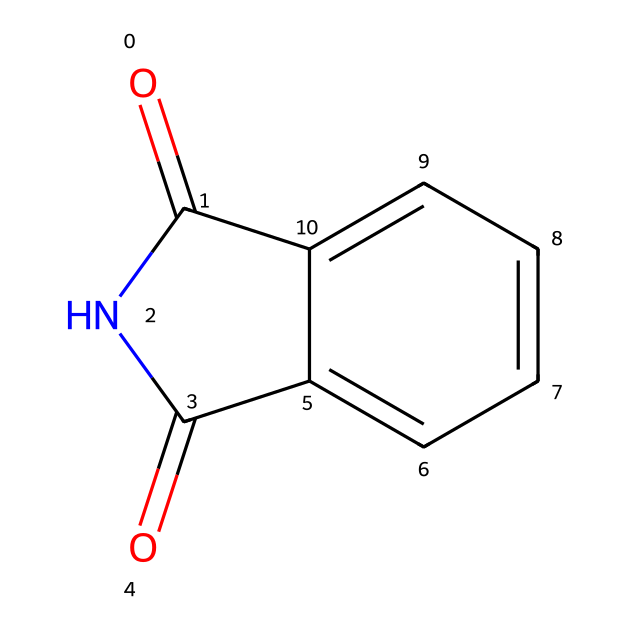What is the molecular formula of phthalimide? To determine the molecular formula, we count the atoms represented in the SMILES. It contains 8 carbon (C) atoms, 5 hydrogen (H) atoms, 2 nitrogen (N) atoms, and 2 oxygen (O) atoms. Thus, the molecular formula is C8H5N2O2.
Answer: C8H5N2O2 How many rings are present in the structure? Analyzing the SMILES, we observe that there is one cyclic structure formed by the connection of atoms. The 'C1NC' notation indicates a ring. Therefore, there is one ring.
Answer: 1 What type of functional group is present in phthalimide? Looking at the structure, we find the imide functional group characterized by the carbonyl (C=O) groups bonded to the nitrogen (N). This structure specifically identifies it as an imide.
Answer: imide What is the degree of unsaturation in phthalimide? Degree of unsaturation is calculated using the formula: (number of rings + number of double bonds - number of hydrogens + 1). The structure has 1 ring and 2 double bonds (C=O), and there are 5 hydrogens, resulting in: (1 + 2 - 5 + 1) = -1. Thus, the degree of unsaturation is 2.
Answer: 2 What is the main application of phthalimide in organic synthesis? Phthalimide is primarily used in organic synthesis as a precursor for the synthesis of various nitrogen-containing compounds. Its structure allows reaction with nucleophiles, making it valuable in creating pharmaceuticals.
Answer: precursor for nitrogen compounds Does phthalimide contain any aromatic characteristics? Upon examining the structure, we identify a benzene ring (c2ccccc2), which confirms the presence of aromatic properties due to the alternating double bonds within the ring structure.
Answer: yes 